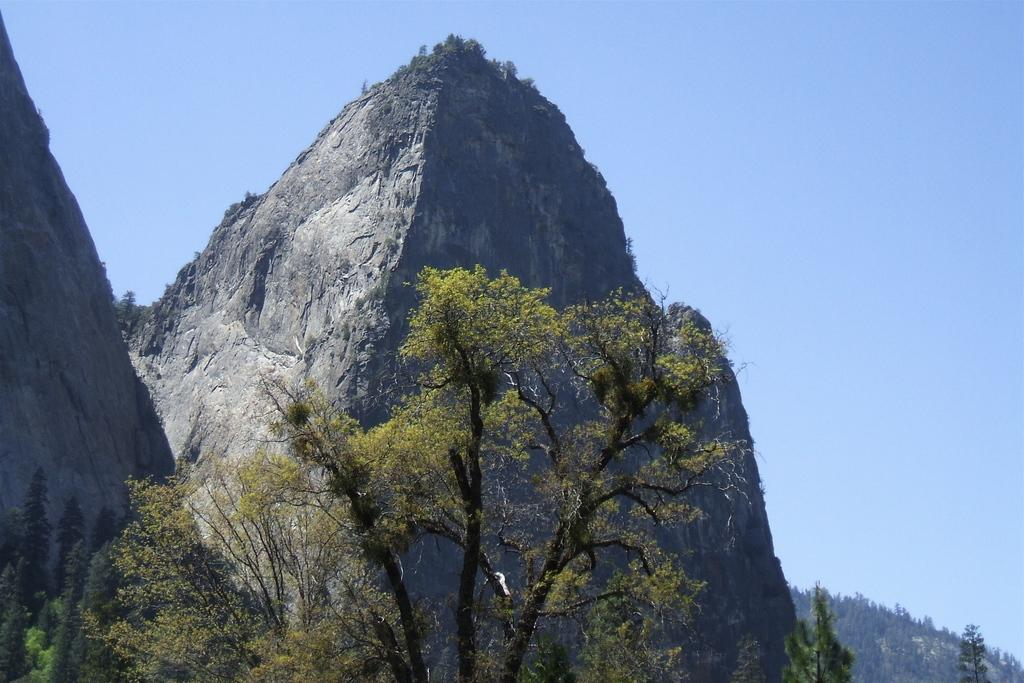What type of vegetation is present in the image? There are many trees in the image. What natural feature can be seen in the distance? There are mountains visible in the background of the image. What color is the sky in the background of the image? The sky is blue in the background of the image. What type of operation is being performed on the trees in the image? There is no operation being performed on the trees in the image; they are simply standing in their natural environment. 